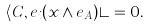<formula> <loc_0><loc_0><loc_500><loc_500>\langle C , e _ { i } ( x \wedge e _ { A } ) \rangle = 0 .</formula> 